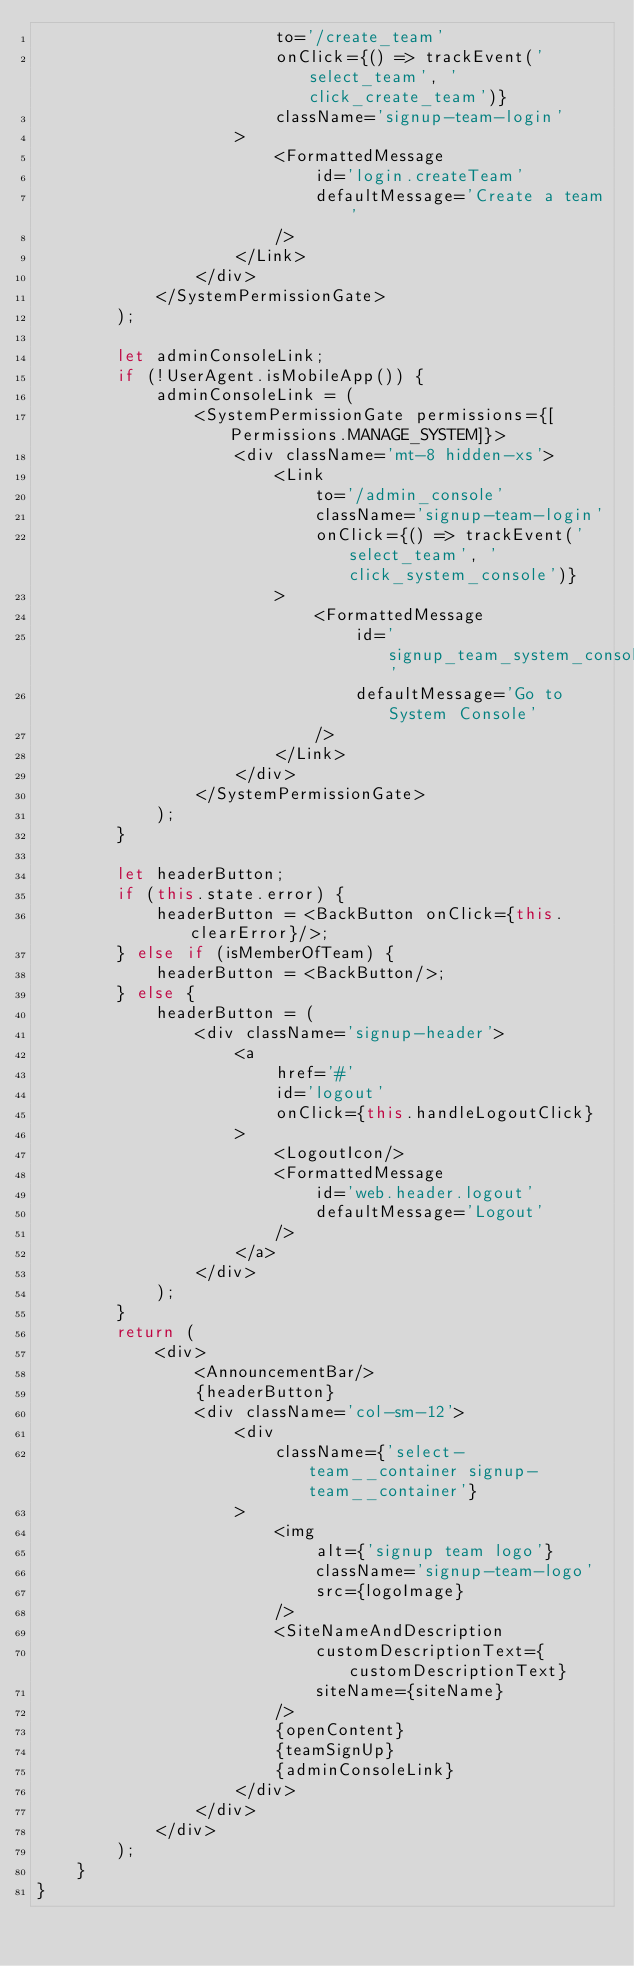Convert code to text. <code><loc_0><loc_0><loc_500><loc_500><_TypeScript_>                        to='/create_team'
                        onClick={() => trackEvent('select_team', 'click_create_team')}
                        className='signup-team-login'
                    >
                        <FormattedMessage
                            id='login.createTeam'
                            defaultMessage='Create a team'
                        />
                    </Link>
                </div>
            </SystemPermissionGate>
        );

        let adminConsoleLink;
        if (!UserAgent.isMobileApp()) {
            adminConsoleLink = (
                <SystemPermissionGate permissions={[Permissions.MANAGE_SYSTEM]}>
                    <div className='mt-8 hidden-xs'>
                        <Link
                            to='/admin_console'
                            className='signup-team-login'
                            onClick={() => trackEvent('select_team', 'click_system_console')}
                        >
                            <FormattedMessage
                                id='signup_team_system_console'
                                defaultMessage='Go to System Console'
                            />
                        </Link>
                    </div>
                </SystemPermissionGate>
            );
        }

        let headerButton;
        if (this.state.error) {
            headerButton = <BackButton onClick={this.clearError}/>;
        } else if (isMemberOfTeam) {
            headerButton = <BackButton/>;
        } else {
            headerButton = (
                <div className='signup-header'>
                    <a
                        href='#'
                        id='logout'
                        onClick={this.handleLogoutClick}
                    >
                        <LogoutIcon/>
                        <FormattedMessage
                            id='web.header.logout'
                            defaultMessage='Logout'
                        />
                    </a>
                </div>
            );
        }
        return (
            <div>
                <AnnouncementBar/>
                {headerButton}
                <div className='col-sm-12'>
                    <div
                        className={'select-team__container signup-team__container'}
                    >
                        <img
                            alt={'signup team logo'}
                            className='signup-team-logo'
                            src={logoImage}
                        />
                        <SiteNameAndDescription
                            customDescriptionText={customDescriptionText}
                            siteName={siteName}
                        />
                        {openContent}
                        {teamSignUp}
                        {adminConsoleLink}
                    </div>
                </div>
            </div>
        );
    }
}
</code> 